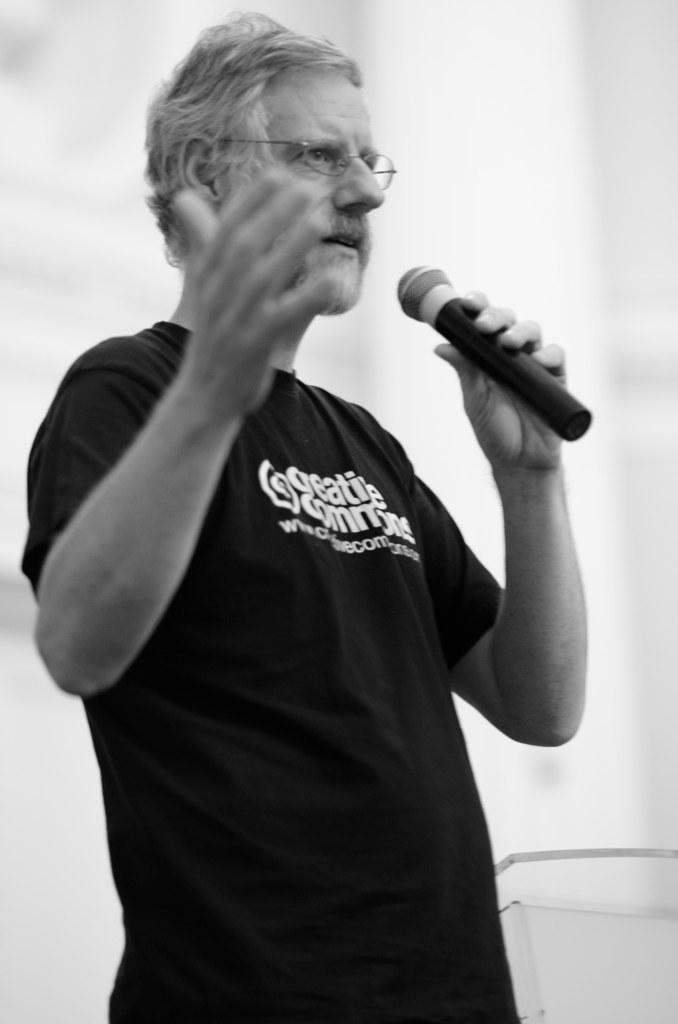Who is present in the image? There is a man in the image. What is the man doing in the image? The man is standing in the image. What is the man wearing in the image? The man is wearing a black t-shirt in the image. What object is the man holding in the image? The man is holding a microphone in his hand in the image. Can you describe the background of the image? The background of the image is blurry. Can you tell me how many boats are docked at the harbor in the image? There is no harbor or boats present in the image; it features a man standing with a microphone. 